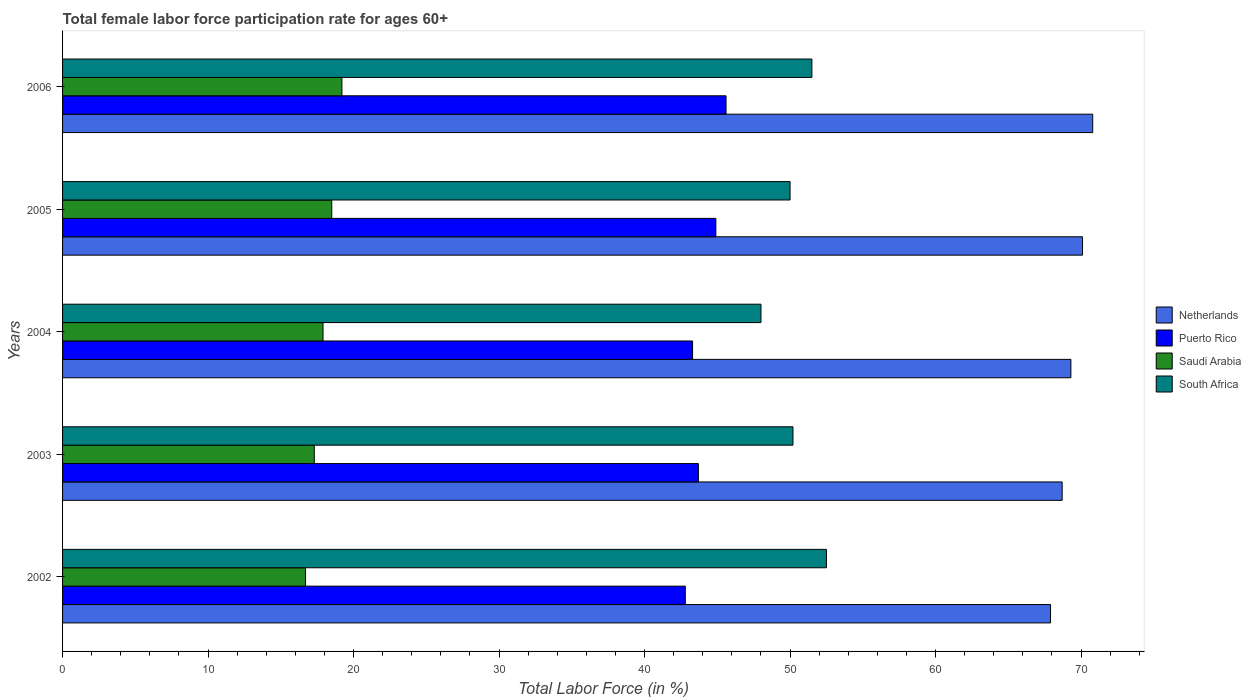How many different coloured bars are there?
Your response must be concise. 4. How many groups of bars are there?
Offer a very short reply. 5. Are the number of bars per tick equal to the number of legend labels?
Provide a succinct answer. Yes. How many bars are there on the 1st tick from the top?
Your answer should be compact. 4. How many bars are there on the 5th tick from the bottom?
Your response must be concise. 4. In how many cases, is the number of bars for a given year not equal to the number of legend labels?
Your answer should be very brief. 0. What is the female labor force participation rate in Saudi Arabia in 2004?
Provide a short and direct response. 17.9. Across all years, what is the maximum female labor force participation rate in South Africa?
Ensure brevity in your answer.  52.5. What is the total female labor force participation rate in Saudi Arabia in the graph?
Make the answer very short. 89.6. What is the difference between the female labor force participation rate in Puerto Rico in 2006 and the female labor force participation rate in Netherlands in 2005?
Keep it short and to the point. -24.5. What is the average female labor force participation rate in Netherlands per year?
Provide a short and direct response. 69.36. In the year 2004, what is the difference between the female labor force participation rate in South Africa and female labor force participation rate in Puerto Rico?
Offer a terse response. 4.7. What is the ratio of the female labor force participation rate in Netherlands in 2002 to that in 2004?
Provide a short and direct response. 0.98. Is the female labor force participation rate in Netherlands in 2002 less than that in 2006?
Your response must be concise. Yes. What is the difference between the highest and the lowest female labor force participation rate in Puerto Rico?
Keep it short and to the point. 2.8. Is the sum of the female labor force participation rate in Puerto Rico in 2002 and 2005 greater than the maximum female labor force participation rate in Saudi Arabia across all years?
Make the answer very short. Yes. What does the 1st bar from the top in 2005 represents?
Ensure brevity in your answer.  South Africa. What does the 2nd bar from the bottom in 2006 represents?
Your response must be concise. Puerto Rico. Are all the bars in the graph horizontal?
Your response must be concise. Yes. How many years are there in the graph?
Your answer should be very brief. 5. What is the difference between two consecutive major ticks on the X-axis?
Provide a succinct answer. 10. Does the graph contain grids?
Your response must be concise. No. How many legend labels are there?
Your answer should be very brief. 4. What is the title of the graph?
Your answer should be very brief. Total female labor force participation rate for ages 60+. What is the Total Labor Force (in %) in Netherlands in 2002?
Your answer should be compact. 67.9. What is the Total Labor Force (in %) of Puerto Rico in 2002?
Give a very brief answer. 42.8. What is the Total Labor Force (in %) in Saudi Arabia in 2002?
Give a very brief answer. 16.7. What is the Total Labor Force (in %) in South Africa in 2002?
Make the answer very short. 52.5. What is the Total Labor Force (in %) in Netherlands in 2003?
Your answer should be compact. 68.7. What is the Total Labor Force (in %) in Puerto Rico in 2003?
Offer a very short reply. 43.7. What is the Total Labor Force (in %) of Saudi Arabia in 2003?
Offer a very short reply. 17.3. What is the Total Labor Force (in %) of South Africa in 2003?
Ensure brevity in your answer.  50.2. What is the Total Labor Force (in %) of Netherlands in 2004?
Give a very brief answer. 69.3. What is the Total Labor Force (in %) in Puerto Rico in 2004?
Keep it short and to the point. 43.3. What is the Total Labor Force (in %) in Saudi Arabia in 2004?
Make the answer very short. 17.9. What is the Total Labor Force (in %) of South Africa in 2004?
Your answer should be very brief. 48. What is the Total Labor Force (in %) of Netherlands in 2005?
Keep it short and to the point. 70.1. What is the Total Labor Force (in %) in Puerto Rico in 2005?
Provide a succinct answer. 44.9. What is the Total Labor Force (in %) of South Africa in 2005?
Your answer should be very brief. 50. What is the Total Labor Force (in %) of Netherlands in 2006?
Your answer should be very brief. 70.8. What is the Total Labor Force (in %) in Puerto Rico in 2006?
Your answer should be very brief. 45.6. What is the Total Labor Force (in %) of Saudi Arabia in 2006?
Your answer should be very brief. 19.2. What is the Total Labor Force (in %) of South Africa in 2006?
Your answer should be very brief. 51.5. Across all years, what is the maximum Total Labor Force (in %) in Netherlands?
Your response must be concise. 70.8. Across all years, what is the maximum Total Labor Force (in %) in Puerto Rico?
Provide a succinct answer. 45.6. Across all years, what is the maximum Total Labor Force (in %) in Saudi Arabia?
Your answer should be very brief. 19.2. Across all years, what is the maximum Total Labor Force (in %) in South Africa?
Your answer should be compact. 52.5. Across all years, what is the minimum Total Labor Force (in %) of Netherlands?
Your answer should be compact. 67.9. Across all years, what is the minimum Total Labor Force (in %) of Puerto Rico?
Provide a succinct answer. 42.8. Across all years, what is the minimum Total Labor Force (in %) of Saudi Arabia?
Make the answer very short. 16.7. Across all years, what is the minimum Total Labor Force (in %) of South Africa?
Keep it short and to the point. 48. What is the total Total Labor Force (in %) in Netherlands in the graph?
Offer a terse response. 346.8. What is the total Total Labor Force (in %) of Puerto Rico in the graph?
Your answer should be compact. 220.3. What is the total Total Labor Force (in %) in Saudi Arabia in the graph?
Your answer should be very brief. 89.6. What is the total Total Labor Force (in %) in South Africa in the graph?
Ensure brevity in your answer.  252.2. What is the difference between the Total Labor Force (in %) of Puerto Rico in 2002 and that in 2003?
Your response must be concise. -0.9. What is the difference between the Total Labor Force (in %) of Netherlands in 2002 and that in 2004?
Ensure brevity in your answer.  -1.4. What is the difference between the Total Labor Force (in %) in Puerto Rico in 2002 and that in 2004?
Give a very brief answer. -0.5. What is the difference between the Total Labor Force (in %) in Puerto Rico in 2002 and that in 2005?
Offer a very short reply. -2.1. What is the difference between the Total Labor Force (in %) in South Africa in 2002 and that in 2005?
Your answer should be compact. 2.5. What is the difference between the Total Labor Force (in %) in Saudi Arabia in 2002 and that in 2006?
Your answer should be compact. -2.5. What is the difference between the Total Labor Force (in %) of Netherlands in 2003 and that in 2004?
Your answer should be very brief. -0.6. What is the difference between the Total Labor Force (in %) of Saudi Arabia in 2003 and that in 2004?
Your answer should be compact. -0.6. What is the difference between the Total Labor Force (in %) in South Africa in 2003 and that in 2004?
Give a very brief answer. 2.2. What is the difference between the Total Labor Force (in %) of Saudi Arabia in 2003 and that in 2005?
Offer a very short reply. -1.2. What is the difference between the Total Labor Force (in %) in South Africa in 2003 and that in 2005?
Give a very brief answer. 0.2. What is the difference between the Total Labor Force (in %) in Puerto Rico in 2003 and that in 2006?
Give a very brief answer. -1.9. What is the difference between the Total Labor Force (in %) of South Africa in 2003 and that in 2006?
Provide a short and direct response. -1.3. What is the difference between the Total Labor Force (in %) of Netherlands in 2004 and that in 2005?
Provide a succinct answer. -0.8. What is the difference between the Total Labor Force (in %) of South Africa in 2004 and that in 2005?
Ensure brevity in your answer.  -2. What is the difference between the Total Labor Force (in %) of Netherlands in 2004 and that in 2006?
Give a very brief answer. -1.5. What is the difference between the Total Labor Force (in %) in Puerto Rico in 2004 and that in 2006?
Offer a very short reply. -2.3. What is the difference between the Total Labor Force (in %) of Saudi Arabia in 2004 and that in 2006?
Keep it short and to the point. -1.3. What is the difference between the Total Labor Force (in %) in Netherlands in 2005 and that in 2006?
Your response must be concise. -0.7. What is the difference between the Total Labor Force (in %) in Puerto Rico in 2005 and that in 2006?
Provide a succinct answer. -0.7. What is the difference between the Total Labor Force (in %) of Netherlands in 2002 and the Total Labor Force (in %) of Puerto Rico in 2003?
Provide a succinct answer. 24.2. What is the difference between the Total Labor Force (in %) of Netherlands in 2002 and the Total Labor Force (in %) of Saudi Arabia in 2003?
Your response must be concise. 50.6. What is the difference between the Total Labor Force (in %) of Puerto Rico in 2002 and the Total Labor Force (in %) of Saudi Arabia in 2003?
Ensure brevity in your answer.  25.5. What is the difference between the Total Labor Force (in %) in Puerto Rico in 2002 and the Total Labor Force (in %) in South Africa in 2003?
Offer a terse response. -7.4. What is the difference between the Total Labor Force (in %) of Saudi Arabia in 2002 and the Total Labor Force (in %) of South Africa in 2003?
Provide a succinct answer. -33.5. What is the difference between the Total Labor Force (in %) in Netherlands in 2002 and the Total Labor Force (in %) in Puerto Rico in 2004?
Keep it short and to the point. 24.6. What is the difference between the Total Labor Force (in %) in Netherlands in 2002 and the Total Labor Force (in %) in South Africa in 2004?
Ensure brevity in your answer.  19.9. What is the difference between the Total Labor Force (in %) in Puerto Rico in 2002 and the Total Labor Force (in %) in Saudi Arabia in 2004?
Ensure brevity in your answer.  24.9. What is the difference between the Total Labor Force (in %) of Saudi Arabia in 2002 and the Total Labor Force (in %) of South Africa in 2004?
Provide a short and direct response. -31.3. What is the difference between the Total Labor Force (in %) of Netherlands in 2002 and the Total Labor Force (in %) of Puerto Rico in 2005?
Keep it short and to the point. 23. What is the difference between the Total Labor Force (in %) of Netherlands in 2002 and the Total Labor Force (in %) of Saudi Arabia in 2005?
Offer a terse response. 49.4. What is the difference between the Total Labor Force (in %) in Puerto Rico in 2002 and the Total Labor Force (in %) in Saudi Arabia in 2005?
Give a very brief answer. 24.3. What is the difference between the Total Labor Force (in %) of Puerto Rico in 2002 and the Total Labor Force (in %) of South Africa in 2005?
Give a very brief answer. -7.2. What is the difference between the Total Labor Force (in %) of Saudi Arabia in 2002 and the Total Labor Force (in %) of South Africa in 2005?
Make the answer very short. -33.3. What is the difference between the Total Labor Force (in %) in Netherlands in 2002 and the Total Labor Force (in %) in Puerto Rico in 2006?
Provide a succinct answer. 22.3. What is the difference between the Total Labor Force (in %) of Netherlands in 2002 and the Total Labor Force (in %) of Saudi Arabia in 2006?
Your answer should be very brief. 48.7. What is the difference between the Total Labor Force (in %) of Puerto Rico in 2002 and the Total Labor Force (in %) of Saudi Arabia in 2006?
Your answer should be compact. 23.6. What is the difference between the Total Labor Force (in %) of Puerto Rico in 2002 and the Total Labor Force (in %) of South Africa in 2006?
Offer a terse response. -8.7. What is the difference between the Total Labor Force (in %) of Saudi Arabia in 2002 and the Total Labor Force (in %) of South Africa in 2006?
Your answer should be compact. -34.8. What is the difference between the Total Labor Force (in %) in Netherlands in 2003 and the Total Labor Force (in %) in Puerto Rico in 2004?
Ensure brevity in your answer.  25.4. What is the difference between the Total Labor Force (in %) of Netherlands in 2003 and the Total Labor Force (in %) of Saudi Arabia in 2004?
Make the answer very short. 50.8. What is the difference between the Total Labor Force (in %) of Netherlands in 2003 and the Total Labor Force (in %) of South Africa in 2004?
Your answer should be very brief. 20.7. What is the difference between the Total Labor Force (in %) of Puerto Rico in 2003 and the Total Labor Force (in %) of Saudi Arabia in 2004?
Provide a short and direct response. 25.8. What is the difference between the Total Labor Force (in %) in Puerto Rico in 2003 and the Total Labor Force (in %) in South Africa in 2004?
Your response must be concise. -4.3. What is the difference between the Total Labor Force (in %) in Saudi Arabia in 2003 and the Total Labor Force (in %) in South Africa in 2004?
Provide a short and direct response. -30.7. What is the difference between the Total Labor Force (in %) in Netherlands in 2003 and the Total Labor Force (in %) in Puerto Rico in 2005?
Your answer should be compact. 23.8. What is the difference between the Total Labor Force (in %) in Netherlands in 2003 and the Total Labor Force (in %) in Saudi Arabia in 2005?
Offer a very short reply. 50.2. What is the difference between the Total Labor Force (in %) of Puerto Rico in 2003 and the Total Labor Force (in %) of Saudi Arabia in 2005?
Make the answer very short. 25.2. What is the difference between the Total Labor Force (in %) of Saudi Arabia in 2003 and the Total Labor Force (in %) of South Africa in 2005?
Keep it short and to the point. -32.7. What is the difference between the Total Labor Force (in %) of Netherlands in 2003 and the Total Labor Force (in %) of Puerto Rico in 2006?
Your answer should be very brief. 23.1. What is the difference between the Total Labor Force (in %) in Netherlands in 2003 and the Total Labor Force (in %) in Saudi Arabia in 2006?
Offer a terse response. 49.5. What is the difference between the Total Labor Force (in %) of Saudi Arabia in 2003 and the Total Labor Force (in %) of South Africa in 2006?
Your answer should be very brief. -34.2. What is the difference between the Total Labor Force (in %) in Netherlands in 2004 and the Total Labor Force (in %) in Puerto Rico in 2005?
Give a very brief answer. 24.4. What is the difference between the Total Labor Force (in %) of Netherlands in 2004 and the Total Labor Force (in %) of Saudi Arabia in 2005?
Give a very brief answer. 50.8. What is the difference between the Total Labor Force (in %) of Netherlands in 2004 and the Total Labor Force (in %) of South Africa in 2005?
Your answer should be compact. 19.3. What is the difference between the Total Labor Force (in %) of Puerto Rico in 2004 and the Total Labor Force (in %) of Saudi Arabia in 2005?
Offer a very short reply. 24.8. What is the difference between the Total Labor Force (in %) of Saudi Arabia in 2004 and the Total Labor Force (in %) of South Africa in 2005?
Your answer should be very brief. -32.1. What is the difference between the Total Labor Force (in %) of Netherlands in 2004 and the Total Labor Force (in %) of Puerto Rico in 2006?
Make the answer very short. 23.7. What is the difference between the Total Labor Force (in %) in Netherlands in 2004 and the Total Labor Force (in %) in Saudi Arabia in 2006?
Your response must be concise. 50.1. What is the difference between the Total Labor Force (in %) of Puerto Rico in 2004 and the Total Labor Force (in %) of Saudi Arabia in 2006?
Ensure brevity in your answer.  24.1. What is the difference between the Total Labor Force (in %) in Saudi Arabia in 2004 and the Total Labor Force (in %) in South Africa in 2006?
Offer a terse response. -33.6. What is the difference between the Total Labor Force (in %) of Netherlands in 2005 and the Total Labor Force (in %) of Puerto Rico in 2006?
Provide a short and direct response. 24.5. What is the difference between the Total Labor Force (in %) of Netherlands in 2005 and the Total Labor Force (in %) of Saudi Arabia in 2006?
Offer a very short reply. 50.9. What is the difference between the Total Labor Force (in %) in Puerto Rico in 2005 and the Total Labor Force (in %) in Saudi Arabia in 2006?
Offer a very short reply. 25.7. What is the difference between the Total Labor Force (in %) in Puerto Rico in 2005 and the Total Labor Force (in %) in South Africa in 2006?
Provide a short and direct response. -6.6. What is the difference between the Total Labor Force (in %) of Saudi Arabia in 2005 and the Total Labor Force (in %) of South Africa in 2006?
Ensure brevity in your answer.  -33. What is the average Total Labor Force (in %) of Netherlands per year?
Your answer should be compact. 69.36. What is the average Total Labor Force (in %) of Puerto Rico per year?
Make the answer very short. 44.06. What is the average Total Labor Force (in %) of Saudi Arabia per year?
Offer a terse response. 17.92. What is the average Total Labor Force (in %) in South Africa per year?
Ensure brevity in your answer.  50.44. In the year 2002, what is the difference between the Total Labor Force (in %) of Netherlands and Total Labor Force (in %) of Puerto Rico?
Make the answer very short. 25.1. In the year 2002, what is the difference between the Total Labor Force (in %) of Netherlands and Total Labor Force (in %) of Saudi Arabia?
Your answer should be compact. 51.2. In the year 2002, what is the difference between the Total Labor Force (in %) of Netherlands and Total Labor Force (in %) of South Africa?
Your answer should be compact. 15.4. In the year 2002, what is the difference between the Total Labor Force (in %) in Puerto Rico and Total Labor Force (in %) in Saudi Arabia?
Offer a terse response. 26.1. In the year 2002, what is the difference between the Total Labor Force (in %) in Puerto Rico and Total Labor Force (in %) in South Africa?
Ensure brevity in your answer.  -9.7. In the year 2002, what is the difference between the Total Labor Force (in %) in Saudi Arabia and Total Labor Force (in %) in South Africa?
Keep it short and to the point. -35.8. In the year 2003, what is the difference between the Total Labor Force (in %) in Netherlands and Total Labor Force (in %) in Saudi Arabia?
Keep it short and to the point. 51.4. In the year 2003, what is the difference between the Total Labor Force (in %) in Puerto Rico and Total Labor Force (in %) in Saudi Arabia?
Provide a succinct answer. 26.4. In the year 2003, what is the difference between the Total Labor Force (in %) in Saudi Arabia and Total Labor Force (in %) in South Africa?
Your response must be concise. -32.9. In the year 2004, what is the difference between the Total Labor Force (in %) in Netherlands and Total Labor Force (in %) in Puerto Rico?
Provide a succinct answer. 26. In the year 2004, what is the difference between the Total Labor Force (in %) in Netherlands and Total Labor Force (in %) in Saudi Arabia?
Provide a short and direct response. 51.4. In the year 2004, what is the difference between the Total Labor Force (in %) in Netherlands and Total Labor Force (in %) in South Africa?
Your answer should be compact. 21.3. In the year 2004, what is the difference between the Total Labor Force (in %) in Puerto Rico and Total Labor Force (in %) in Saudi Arabia?
Offer a very short reply. 25.4. In the year 2004, what is the difference between the Total Labor Force (in %) of Saudi Arabia and Total Labor Force (in %) of South Africa?
Your answer should be very brief. -30.1. In the year 2005, what is the difference between the Total Labor Force (in %) of Netherlands and Total Labor Force (in %) of Puerto Rico?
Provide a succinct answer. 25.2. In the year 2005, what is the difference between the Total Labor Force (in %) of Netherlands and Total Labor Force (in %) of Saudi Arabia?
Give a very brief answer. 51.6. In the year 2005, what is the difference between the Total Labor Force (in %) in Netherlands and Total Labor Force (in %) in South Africa?
Keep it short and to the point. 20.1. In the year 2005, what is the difference between the Total Labor Force (in %) in Puerto Rico and Total Labor Force (in %) in Saudi Arabia?
Your answer should be very brief. 26.4. In the year 2005, what is the difference between the Total Labor Force (in %) in Puerto Rico and Total Labor Force (in %) in South Africa?
Provide a short and direct response. -5.1. In the year 2005, what is the difference between the Total Labor Force (in %) in Saudi Arabia and Total Labor Force (in %) in South Africa?
Your answer should be very brief. -31.5. In the year 2006, what is the difference between the Total Labor Force (in %) in Netherlands and Total Labor Force (in %) in Puerto Rico?
Provide a succinct answer. 25.2. In the year 2006, what is the difference between the Total Labor Force (in %) in Netherlands and Total Labor Force (in %) in Saudi Arabia?
Provide a short and direct response. 51.6. In the year 2006, what is the difference between the Total Labor Force (in %) of Netherlands and Total Labor Force (in %) of South Africa?
Ensure brevity in your answer.  19.3. In the year 2006, what is the difference between the Total Labor Force (in %) in Puerto Rico and Total Labor Force (in %) in Saudi Arabia?
Your answer should be very brief. 26.4. In the year 2006, what is the difference between the Total Labor Force (in %) of Puerto Rico and Total Labor Force (in %) of South Africa?
Make the answer very short. -5.9. In the year 2006, what is the difference between the Total Labor Force (in %) of Saudi Arabia and Total Labor Force (in %) of South Africa?
Offer a terse response. -32.3. What is the ratio of the Total Labor Force (in %) of Netherlands in 2002 to that in 2003?
Provide a short and direct response. 0.99. What is the ratio of the Total Labor Force (in %) in Puerto Rico in 2002 to that in 2003?
Your response must be concise. 0.98. What is the ratio of the Total Labor Force (in %) of Saudi Arabia in 2002 to that in 2003?
Make the answer very short. 0.97. What is the ratio of the Total Labor Force (in %) of South Africa in 2002 to that in 2003?
Your response must be concise. 1.05. What is the ratio of the Total Labor Force (in %) in Netherlands in 2002 to that in 2004?
Offer a terse response. 0.98. What is the ratio of the Total Labor Force (in %) in Saudi Arabia in 2002 to that in 2004?
Keep it short and to the point. 0.93. What is the ratio of the Total Labor Force (in %) of South Africa in 2002 to that in 2004?
Your response must be concise. 1.09. What is the ratio of the Total Labor Force (in %) in Netherlands in 2002 to that in 2005?
Make the answer very short. 0.97. What is the ratio of the Total Labor Force (in %) in Puerto Rico in 2002 to that in 2005?
Give a very brief answer. 0.95. What is the ratio of the Total Labor Force (in %) of Saudi Arabia in 2002 to that in 2005?
Provide a short and direct response. 0.9. What is the ratio of the Total Labor Force (in %) in South Africa in 2002 to that in 2005?
Give a very brief answer. 1.05. What is the ratio of the Total Labor Force (in %) of Puerto Rico in 2002 to that in 2006?
Make the answer very short. 0.94. What is the ratio of the Total Labor Force (in %) in Saudi Arabia in 2002 to that in 2006?
Ensure brevity in your answer.  0.87. What is the ratio of the Total Labor Force (in %) of South Africa in 2002 to that in 2006?
Ensure brevity in your answer.  1.02. What is the ratio of the Total Labor Force (in %) in Puerto Rico in 2003 to that in 2004?
Offer a very short reply. 1.01. What is the ratio of the Total Labor Force (in %) in Saudi Arabia in 2003 to that in 2004?
Make the answer very short. 0.97. What is the ratio of the Total Labor Force (in %) of South Africa in 2003 to that in 2004?
Give a very brief answer. 1.05. What is the ratio of the Total Labor Force (in %) of Netherlands in 2003 to that in 2005?
Provide a succinct answer. 0.98. What is the ratio of the Total Labor Force (in %) in Puerto Rico in 2003 to that in 2005?
Offer a very short reply. 0.97. What is the ratio of the Total Labor Force (in %) of Saudi Arabia in 2003 to that in 2005?
Your answer should be very brief. 0.94. What is the ratio of the Total Labor Force (in %) of South Africa in 2003 to that in 2005?
Offer a terse response. 1. What is the ratio of the Total Labor Force (in %) in Netherlands in 2003 to that in 2006?
Provide a short and direct response. 0.97. What is the ratio of the Total Labor Force (in %) of Puerto Rico in 2003 to that in 2006?
Provide a succinct answer. 0.96. What is the ratio of the Total Labor Force (in %) in Saudi Arabia in 2003 to that in 2006?
Provide a short and direct response. 0.9. What is the ratio of the Total Labor Force (in %) in South Africa in 2003 to that in 2006?
Offer a terse response. 0.97. What is the ratio of the Total Labor Force (in %) in Netherlands in 2004 to that in 2005?
Your answer should be compact. 0.99. What is the ratio of the Total Labor Force (in %) of Puerto Rico in 2004 to that in 2005?
Offer a very short reply. 0.96. What is the ratio of the Total Labor Force (in %) in Saudi Arabia in 2004 to that in 2005?
Keep it short and to the point. 0.97. What is the ratio of the Total Labor Force (in %) of South Africa in 2004 to that in 2005?
Provide a succinct answer. 0.96. What is the ratio of the Total Labor Force (in %) of Netherlands in 2004 to that in 2006?
Your answer should be compact. 0.98. What is the ratio of the Total Labor Force (in %) in Puerto Rico in 2004 to that in 2006?
Keep it short and to the point. 0.95. What is the ratio of the Total Labor Force (in %) of Saudi Arabia in 2004 to that in 2006?
Provide a short and direct response. 0.93. What is the ratio of the Total Labor Force (in %) of South Africa in 2004 to that in 2006?
Your answer should be very brief. 0.93. What is the ratio of the Total Labor Force (in %) in Puerto Rico in 2005 to that in 2006?
Give a very brief answer. 0.98. What is the ratio of the Total Labor Force (in %) of Saudi Arabia in 2005 to that in 2006?
Make the answer very short. 0.96. What is the ratio of the Total Labor Force (in %) in South Africa in 2005 to that in 2006?
Make the answer very short. 0.97. What is the difference between the highest and the second highest Total Labor Force (in %) of Netherlands?
Provide a succinct answer. 0.7. What is the difference between the highest and the second highest Total Labor Force (in %) in Saudi Arabia?
Your answer should be compact. 0.7. What is the difference between the highest and the second highest Total Labor Force (in %) in South Africa?
Your answer should be very brief. 1. What is the difference between the highest and the lowest Total Labor Force (in %) in Netherlands?
Offer a terse response. 2.9. What is the difference between the highest and the lowest Total Labor Force (in %) of Puerto Rico?
Provide a short and direct response. 2.8. 